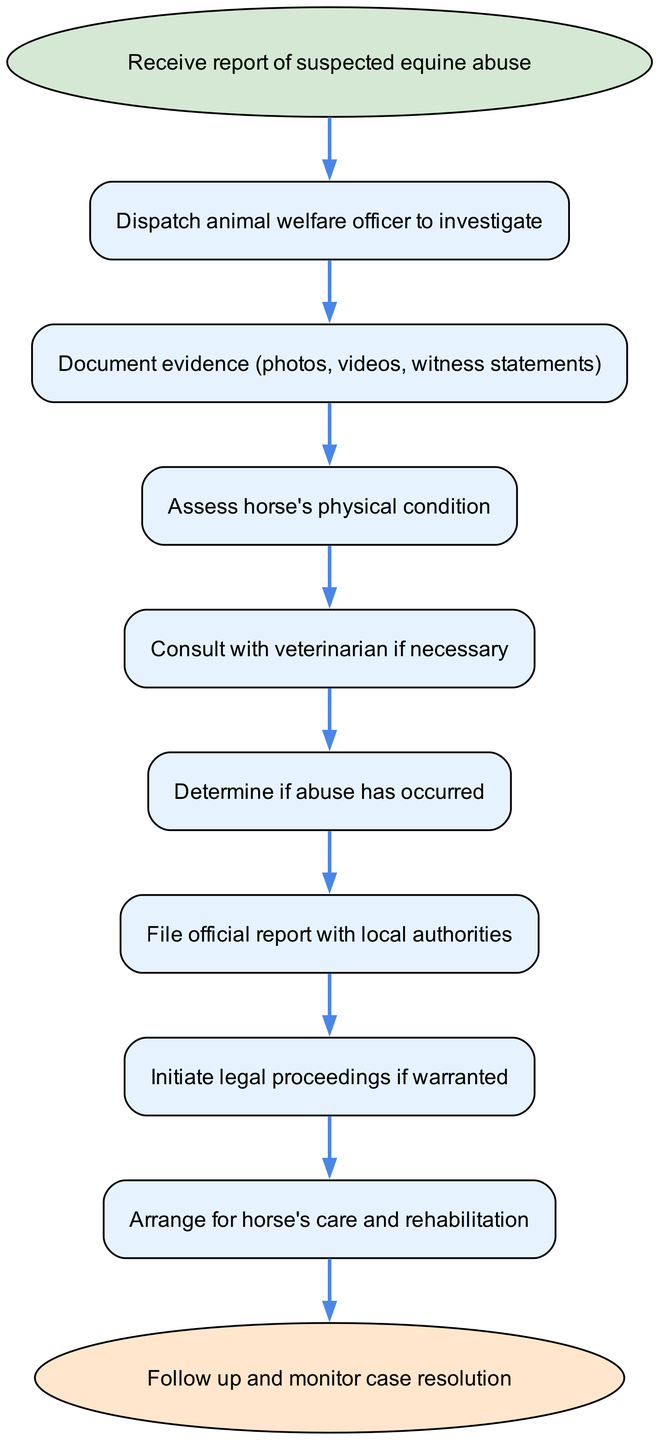What is the first step in the procedure? The first step in the procedure is receiving a report of suspected equine abuse, which is indicated by the starting node in the diagram.
Answer: Receive report of suspected equine abuse How many total nodes are present in the diagram? To find the total number of nodes, we can count each unique element from the data provided in the diagram. There are ten nodes: start, 1, 2, 3, 4, 5, 6, 7, 8, and end.
Answer: 10 What action follows the documentation of evidence? After documenting evidence, the next action is to assess the horse's physical condition, as indicated by the connection from node 2 to node 3.
Answer: Assess horse's physical condition Which node requires consultation with a veterinarian? The consultation with a veterinarian is indicated as a necessary action in node 4, which follows the assessment of the horse's physical condition.
Answer: Consult with veterinarian if necessary What is the last step in the procedure? The last step in the procedure is to follow up and monitor case resolution, which is shown as the endpoint in the diagram.
Answer: Follow up and monitor case resolution How does the procedure progress from determining if abuse has occurred? After determining if abuse has occurred in node 5, the procedure progresses to filing an official report with local authorities in node 6, indicating the flow of actions following that decision.
Answer: File official report with local authorities What happens after legal proceedings are initiated? After initiating legal proceedings in node 7, the next step is to arrange for the horse's care and rehabilitation, as indicated by the connection from node 7 to node 8.
Answer: Arrange for horse's care and rehabilitation 